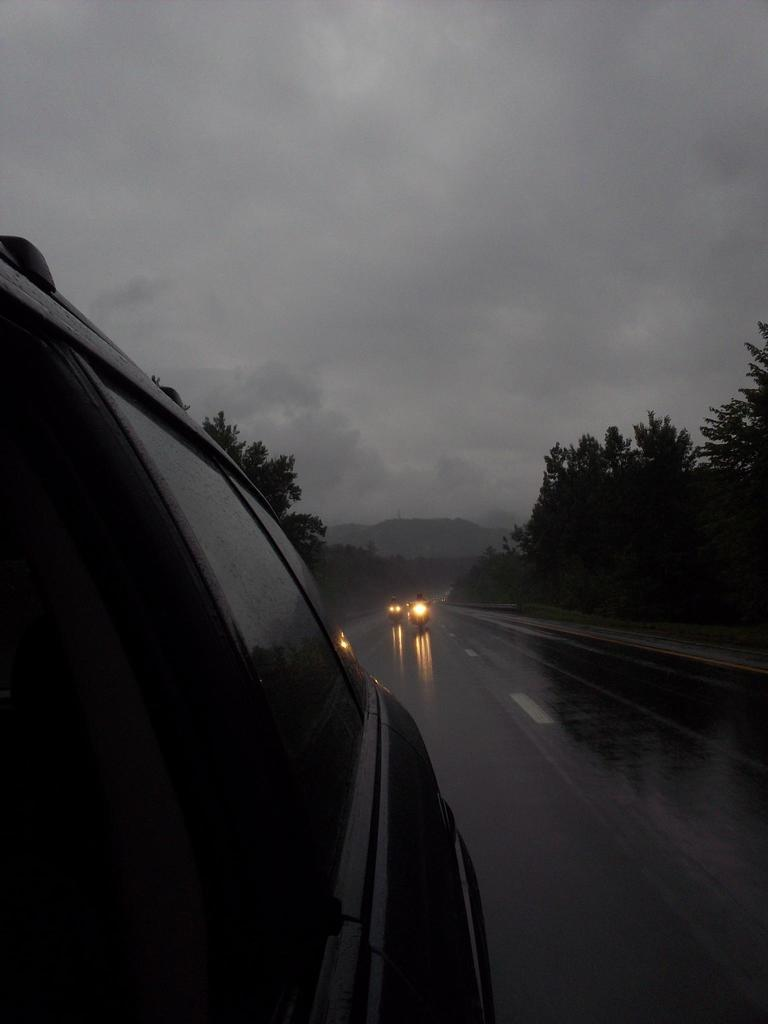What is the main feature of the image? There is a road in the image. What is happening on the road? There are vehicles on the road. What type of natural elements can be seen in the image? There are trees in the image. What is visible in the background of the image? The sky is visible in the image. Can you see any attempts to escape from the quicksand in the image? There is no quicksand present in the image, so it is not possible to see any attempts to escape from it. 